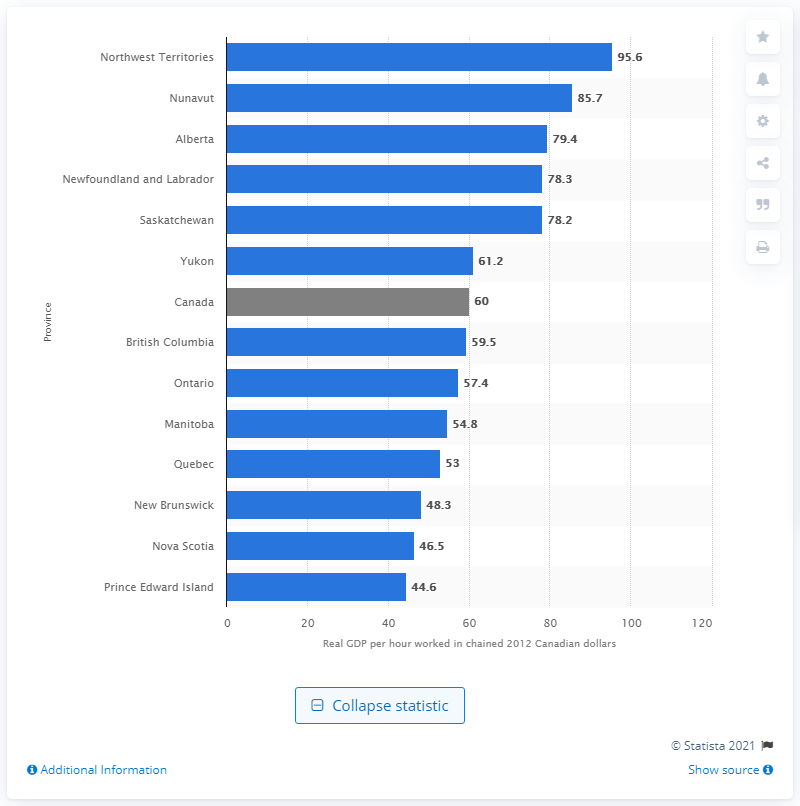List a handful of essential elements in this visual. The labor productivity in the Northwest Territories in 2012 was 95.6%. 